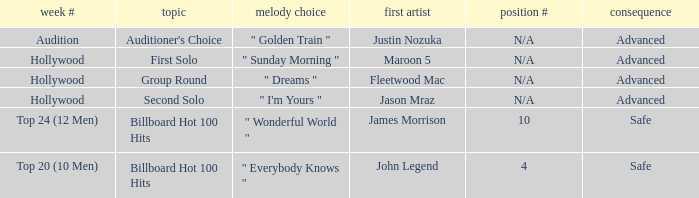What are all the topic wherein music preference is " golden train " Auditioner's Choice. 